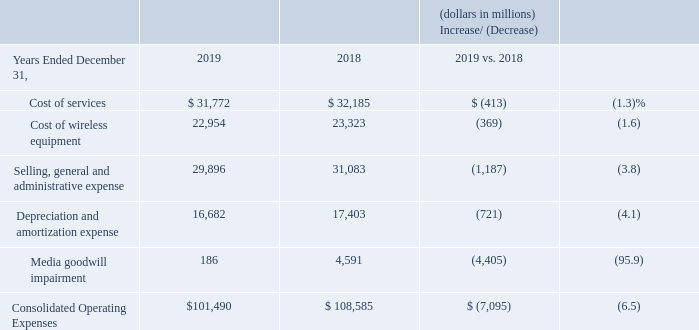Consolidated Operating Expenses
Operating expenses for our segments are discussed separately below under the heading “Segment Results of Operations.”
Cost of Services Cost of services includes the following costs directly attributable to a service: salaries and wages, benefits, materials and supplies, content costs, contracted services, network access and transport costs, customer provisioning costs, computer systems support, and costs to support our outsourcing contracts and technical facilities. Aggregate customer care costs, which include billing and service provisioning, are allocated between Cost of services and Selling, general and administrative expense.
Cost of services decreased $413 million, or 1.3%, during 2019 compared to 2018, primarily due to decreases in network access costs, a product realignment charge in 2018 (see “Special Items”), decreases in employee-related costs resulting from the Voluntary Separation Program and decreases in digital content costs.
These decreases were partially offset by increases in rent expense as a result of adding capacity to the networks to support demand and the adoption of the new lease accounting standard in 2019, regulatory fees, and costs related to the device protection package offered to our wireless retail postpaid customers.
Cost of Wireless Equipment Cost of wireless equipment decreased $369 million, or 1.6%, during 2019 compared to 2018, primarily as a result of declines in the number of wireless devices sold as a result of an elongation of the handset upgrade cycle, partially offset by a shift to higher priced devices in the mix of wireless devices sold.
Selling, General and Administrative Expense Selling, general and administrative expense includes salaries and wages and benefits not directly attributable to a service or product, bad debt charges, taxes other than income taxes, advertising and sales commission costs, call center and information technology costs, regulatory fees, professional service fees, and rent and utilities for administrative space. Also included is a portion of the aggregate customer care costs as discussed above in “Cost of Services.”
Selling, general and administrative expense decreased $1.2 billion, or 3.8%, during 2019 compared to 2018, primarily due to decreases in employee-related costs primarily due to the Voluntary Separation Program, a decrease in severance, pension and benefits charges (see “Special Items”),
the acquisition and integration related charges in 2018 primarily related to the acquisition of Yahoo’s operating business (see “Special Items”) and a net gain from dispositions of assets and businesses in 2019 (see “Special Items”), partially offset by increases in advertising expenses, sales commission and bad debt expense. The increase in sales commission expense during 2019 compared to 2018, was primarily due to a lower net deferral of commission costs as a result of the adoption of Topic 606 on January 1, 2018, using a modified retrospective approach.
Depreciation and Amortization Expense Depreciation and amortization expense decreased $721 million, or 4.1%, during 2019 compared to 2018, primarily due to the change in the mix of net depreciable assets. Media Goodwill Impairment The goodwill impairment charges recorded in 2019 and 2018 for Verizon Media were a result of the Company’s annual impairment test performed in the fourth quarter (see “Critical Accounting Estimates”).
Media Goodwill Impairment The goodwill impairment charges recorded in 2019 and 2018 for Verizon Media were a result of the Company’s annual impairment test performed in the fourth quarter (see “Critical Accounting Estimates”).
What was the decrease in the cost of services in 2019? $413 million. What caused the decrease in the cost of services? Decreases in network access costs, a product realignment charge in 2018 (see “special items”), decreases in employee-related costs resulting from the voluntary separation program and decreases in digital content costs. What was the decrease in the cost of wireless equipment cost in 2019? $369 million. What was the change in the cost of services from 2018 to 2019?
Answer scale should be: million. 31,772 - 32,185
Answer: -413. What was the average cost of wireless equipment for 2018 and 2019?
Answer scale should be: million. (22,954 + 23,323) / 2
Answer: 23138.5. What was the average Selling, general and administrative expense for 2018 and 2019?
Answer scale should be: million. (29,896 + 31,083) / 2
Answer: 30489.5. 